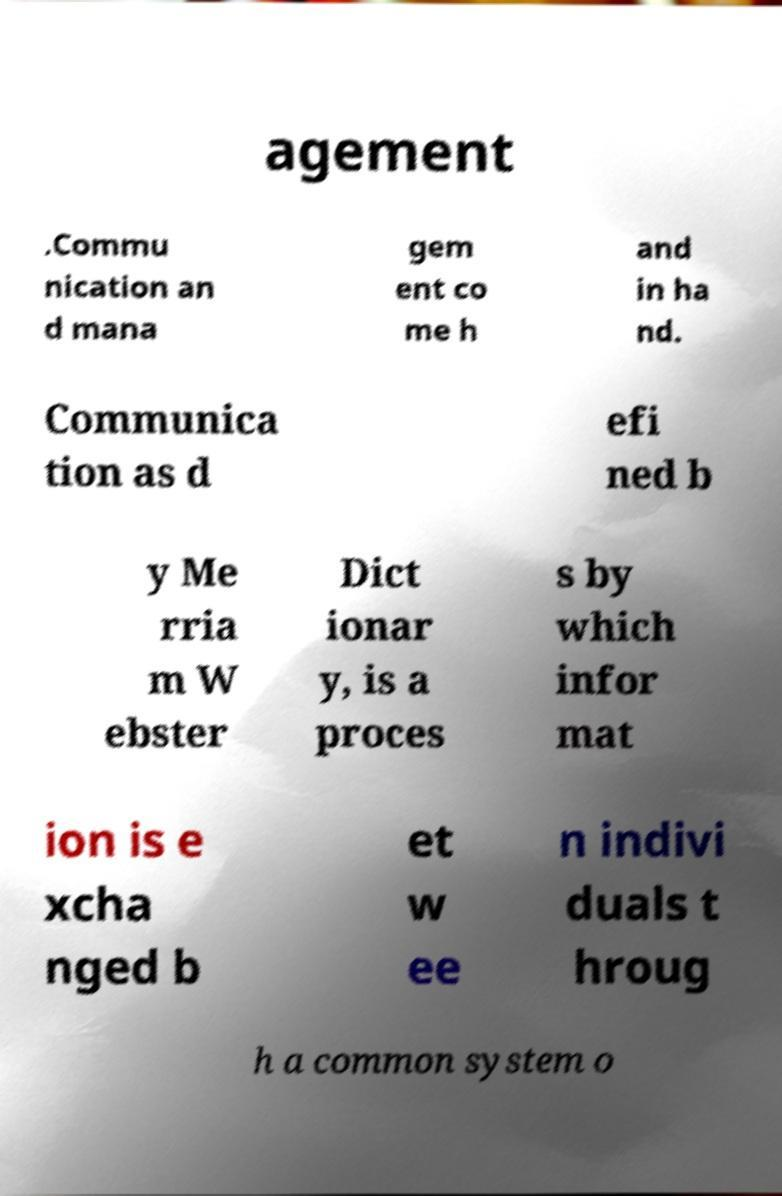Could you assist in decoding the text presented in this image and type it out clearly? agement .Commu nication an d mana gem ent co me h and in ha nd. Communica tion as d efi ned b y Me rria m W ebster Dict ionar y, is a proces s by which infor mat ion is e xcha nged b et w ee n indivi duals t hroug h a common system o 